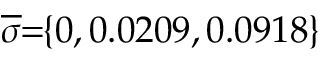Convert formula to latex. <formula><loc_0><loc_0><loc_500><loc_500>\, \overline { \sigma } \, = \, \{ 0 , 0 . 0 2 0 9 , 0 . 0 9 1 8 \} \,</formula> 